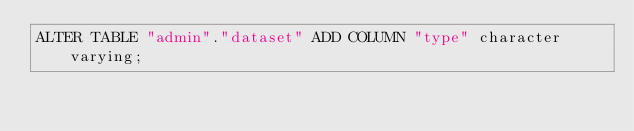<code> <loc_0><loc_0><loc_500><loc_500><_SQL_>ALTER TABLE "admin"."dataset" ADD COLUMN "type" character varying;</code> 